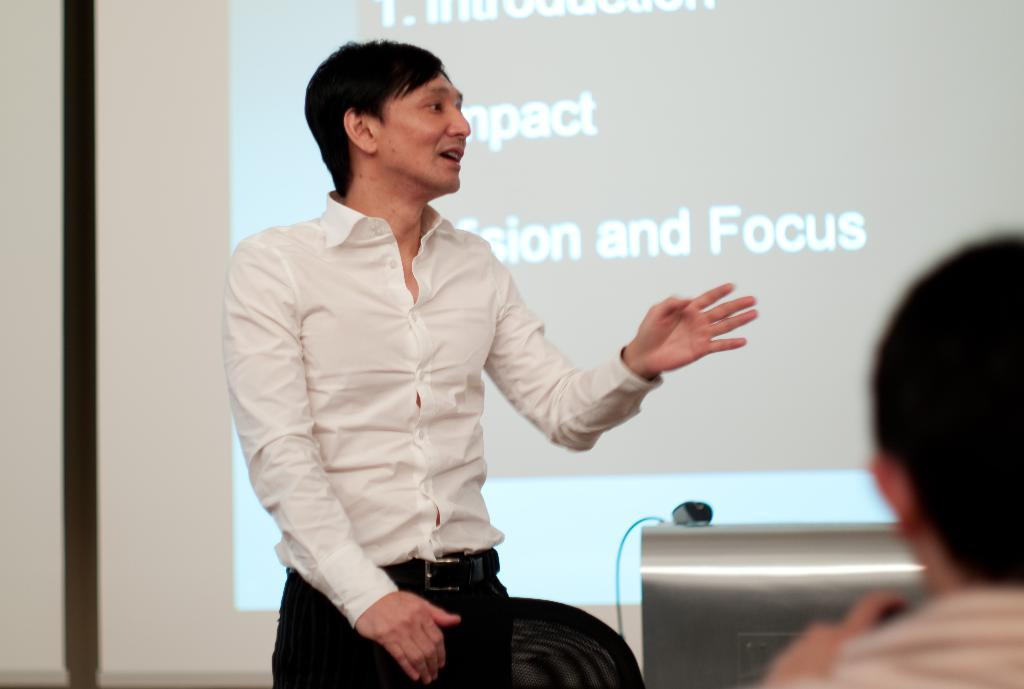What is the man in the image doing? The man is standing in the image. What is the man wearing? The man is wearing a white color shirt. Who else is present in the image? There is a person sitting at the right side of the image. What can be seen in the background of the image? There is a powerpoint presentation in the background of the image. What language is the doll speaking in the image? There is no doll present in the image, so it is not possible to determine the language being spoken. 